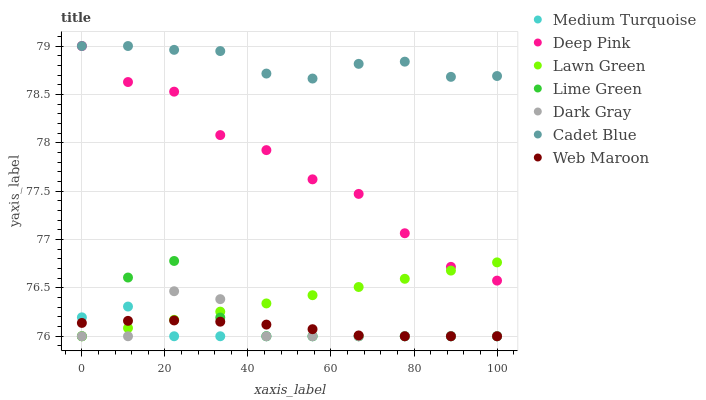Does Medium Turquoise have the minimum area under the curve?
Answer yes or no. Yes. Does Cadet Blue have the maximum area under the curve?
Answer yes or no. Yes. Does Web Maroon have the minimum area under the curve?
Answer yes or no. No. Does Web Maroon have the maximum area under the curve?
Answer yes or no. No. Is Lawn Green the smoothest?
Answer yes or no. Yes. Is Lime Green the roughest?
Answer yes or no. Yes. Is Cadet Blue the smoothest?
Answer yes or no. No. Is Cadet Blue the roughest?
Answer yes or no. No. Does Lawn Green have the lowest value?
Answer yes or no. Yes. Does Cadet Blue have the lowest value?
Answer yes or no. No. Does Deep Pink have the highest value?
Answer yes or no. Yes. Does Web Maroon have the highest value?
Answer yes or no. No. Is Lime Green less than Deep Pink?
Answer yes or no. Yes. Is Deep Pink greater than Dark Gray?
Answer yes or no. Yes. Does Lawn Green intersect Deep Pink?
Answer yes or no. Yes. Is Lawn Green less than Deep Pink?
Answer yes or no. No. Is Lawn Green greater than Deep Pink?
Answer yes or no. No. Does Lime Green intersect Deep Pink?
Answer yes or no. No. 